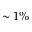<formula> <loc_0><loc_0><loc_500><loc_500>\sim 1 \%</formula> 